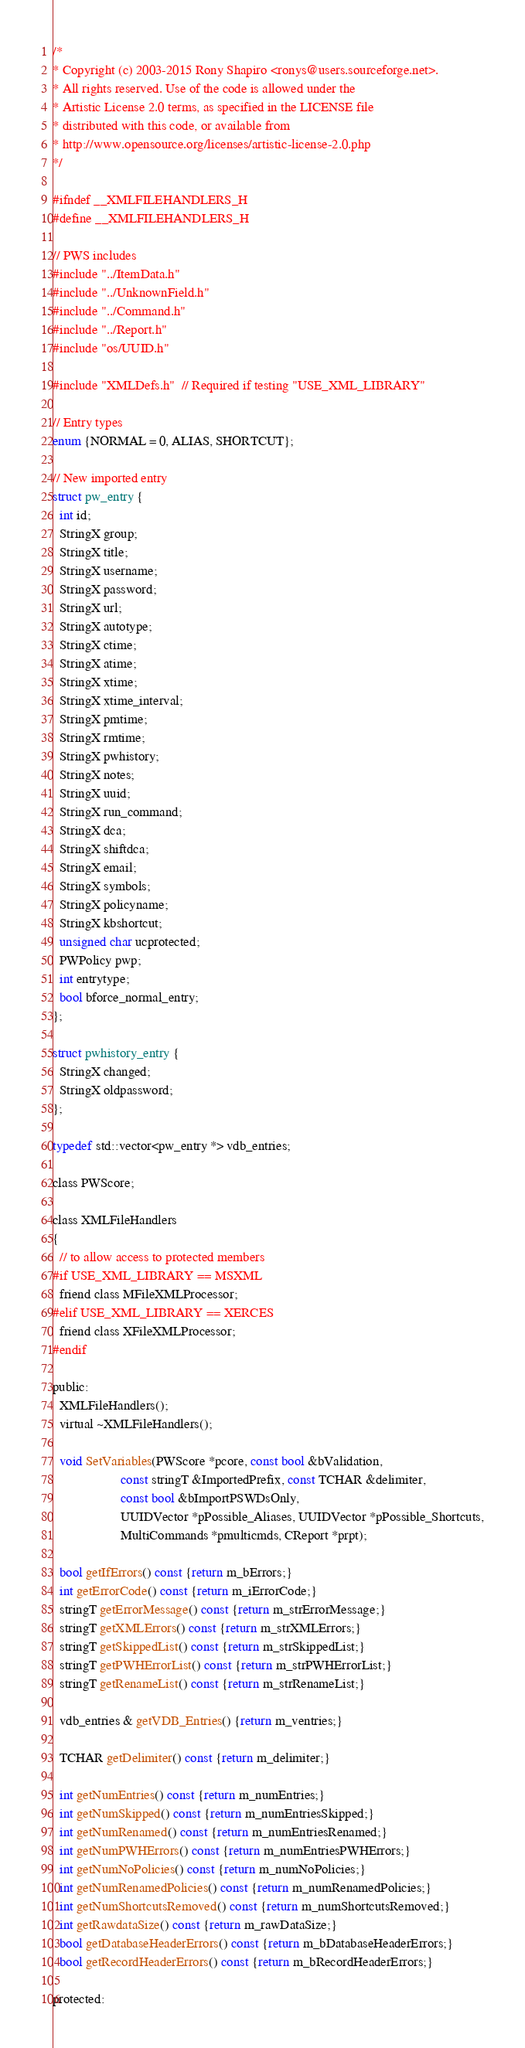<code> <loc_0><loc_0><loc_500><loc_500><_C_>/*
* Copyright (c) 2003-2015 Rony Shapiro <ronys@users.sourceforge.net>.
* All rights reserved. Use of the code is allowed under the
* Artistic License 2.0 terms, as specified in the LICENSE file
* distributed with this code, or available from
* http://www.opensource.org/licenses/artistic-license-2.0.php
*/

#ifndef __XMLFILEHANDLERS_H
#define __XMLFILEHANDLERS_H

// PWS includes
#include "../ItemData.h"
#include "../UnknownField.h"
#include "../Command.h"
#include "../Report.h"
#include "os/UUID.h"

#include "XMLDefs.h"  // Required if testing "USE_XML_LIBRARY"

// Entry types
enum {NORMAL = 0, ALIAS, SHORTCUT};

// New imported entry
struct pw_entry {
  int id;
  StringX group;
  StringX title;
  StringX username;
  StringX password;
  StringX url;
  StringX autotype;
  StringX ctime;
  StringX atime;
  StringX xtime;
  StringX xtime_interval;
  StringX pmtime;
  StringX rmtime;
  StringX pwhistory;
  StringX notes;
  StringX uuid;
  StringX run_command;
  StringX dca;
  StringX shiftdca;
  StringX email;
  StringX symbols;
  StringX policyname;
  StringX kbshortcut;
  unsigned char ucprotected;
  PWPolicy pwp;
  int entrytype;
  bool bforce_normal_entry;
};

struct pwhistory_entry {
  StringX changed;
  StringX oldpassword;
};

typedef std::vector<pw_entry *> vdb_entries;

class PWScore;

class XMLFileHandlers
{
  // to allow access to protected members
#if USE_XML_LIBRARY == MSXML
  friend class MFileXMLProcessor;
#elif USE_XML_LIBRARY == XERCES
  friend class XFileXMLProcessor;
#endif

public:
  XMLFileHandlers();
  virtual ~XMLFileHandlers();

  void SetVariables(PWScore *pcore, const bool &bValidation,
                    const stringT &ImportedPrefix, const TCHAR &delimiter,
                    const bool &bImportPSWDsOnly,
                    UUIDVector *pPossible_Aliases, UUIDVector *pPossible_Shortcuts,
                    MultiCommands *pmulticmds, CReport *prpt);

  bool getIfErrors() const {return m_bErrors;}
  int getErrorCode() const {return m_iErrorCode;}
  stringT getErrorMessage() const {return m_strErrorMessage;}
  stringT getXMLErrors() const {return m_strXMLErrors;}
  stringT getSkippedList() const {return m_strSkippedList;}
  stringT getPWHErrorList() const {return m_strPWHErrorList;}
  stringT getRenameList() const {return m_strRenameList;}

  vdb_entries & getVDB_Entries() {return m_ventries;}

  TCHAR getDelimiter() const {return m_delimiter;}

  int getNumEntries() const {return m_numEntries;}
  int getNumSkipped() const {return m_numEntriesSkipped;}
  int getNumRenamed() const {return m_numEntriesRenamed;}
  int getNumPWHErrors() const {return m_numEntriesPWHErrors;}
  int getNumNoPolicies() const {return m_numNoPolicies;}
  int getNumRenamedPolicies() const {return m_numRenamedPolicies;}
  int getNumShortcutsRemoved() const {return m_numShortcutsRemoved;}
  int getRawdataSize() const {return m_rawDataSize;}
  bool getDatabaseHeaderErrors() const {return m_bDatabaseHeaderErrors;}
  bool getRecordHeaderErrors() const {return m_bRecordHeaderErrors;}

protected:</code> 